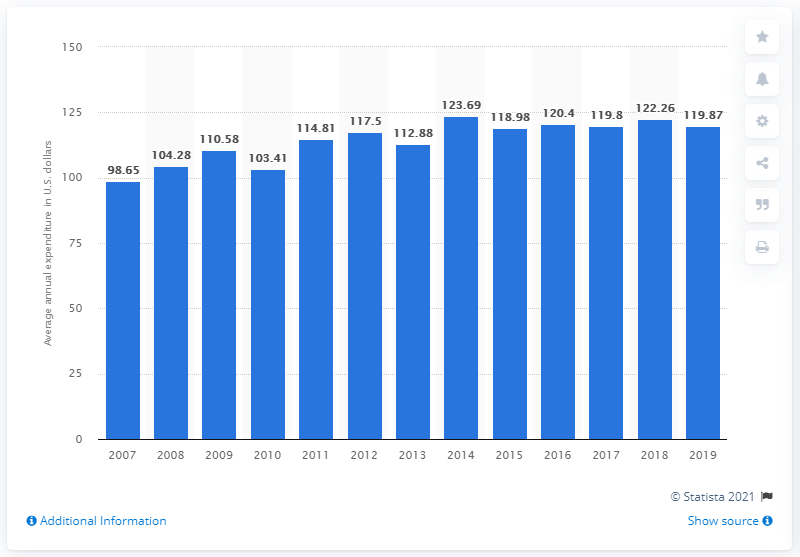Mention a couple of crucial points in this snapshot. In 2017, the average expenditure on cleaning and toilet tissue, paper towels, and napkins per consumer unit was 119.8$. 